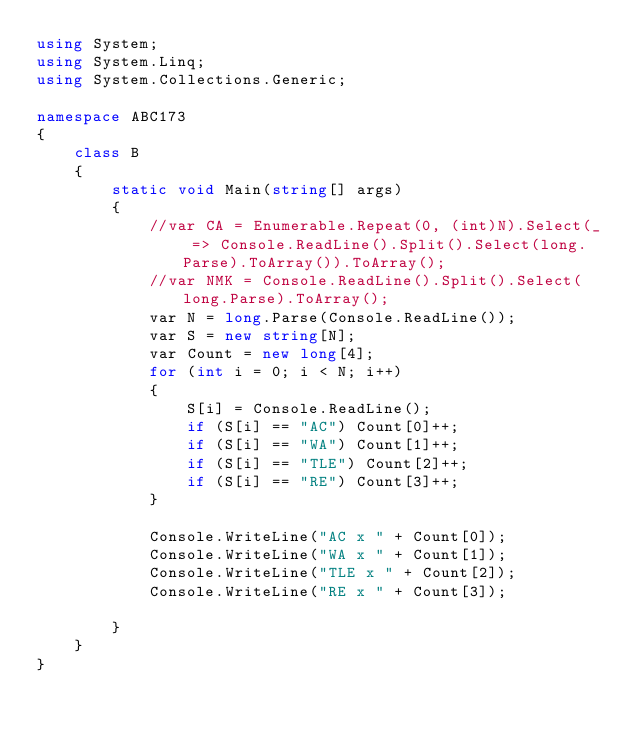<code> <loc_0><loc_0><loc_500><loc_500><_C#_>using System;
using System.Linq;
using System.Collections.Generic;

namespace ABC173
{
    class B
    {
        static void Main(string[] args)
        {
            //var CA = Enumerable.Repeat(0, (int)N).Select(_ => Console.ReadLine().Split().Select(long.Parse).ToArray()).ToArray();
            //var NMK = Console.ReadLine().Split().Select(long.Parse).ToArray();
            var N = long.Parse(Console.ReadLine());
            var S = new string[N];
            var Count = new long[4];
            for (int i = 0; i < N; i++)
            {
                S[i] = Console.ReadLine();
                if (S[i] == "AC") Count[0]++;
                if (S[i] == "WA") Count[1]++;
                if (S[i] == "TLE") Count[2]++;
                if (S[i] == "RE") Count[3]++;
            }

            Console.WriteLine("AC x " + Count[0]);
            Console.WriteLine("WA x " + Count[1]);
            Console.WriteLine("TLE x " + Count[2]);
            Console.WriteLine("RE x " + Count[3]);

        }
    }
}
</code> 